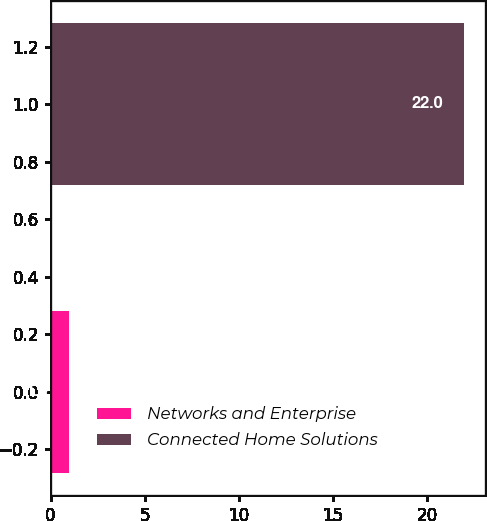<chart> <loc_0><loc_0><loc_500><loc_500><bar_chart><fcel>Networks and Enterprise<fcel>Connected Home Solutions<nl><fcel>1<fcel>22<nl></chart> 